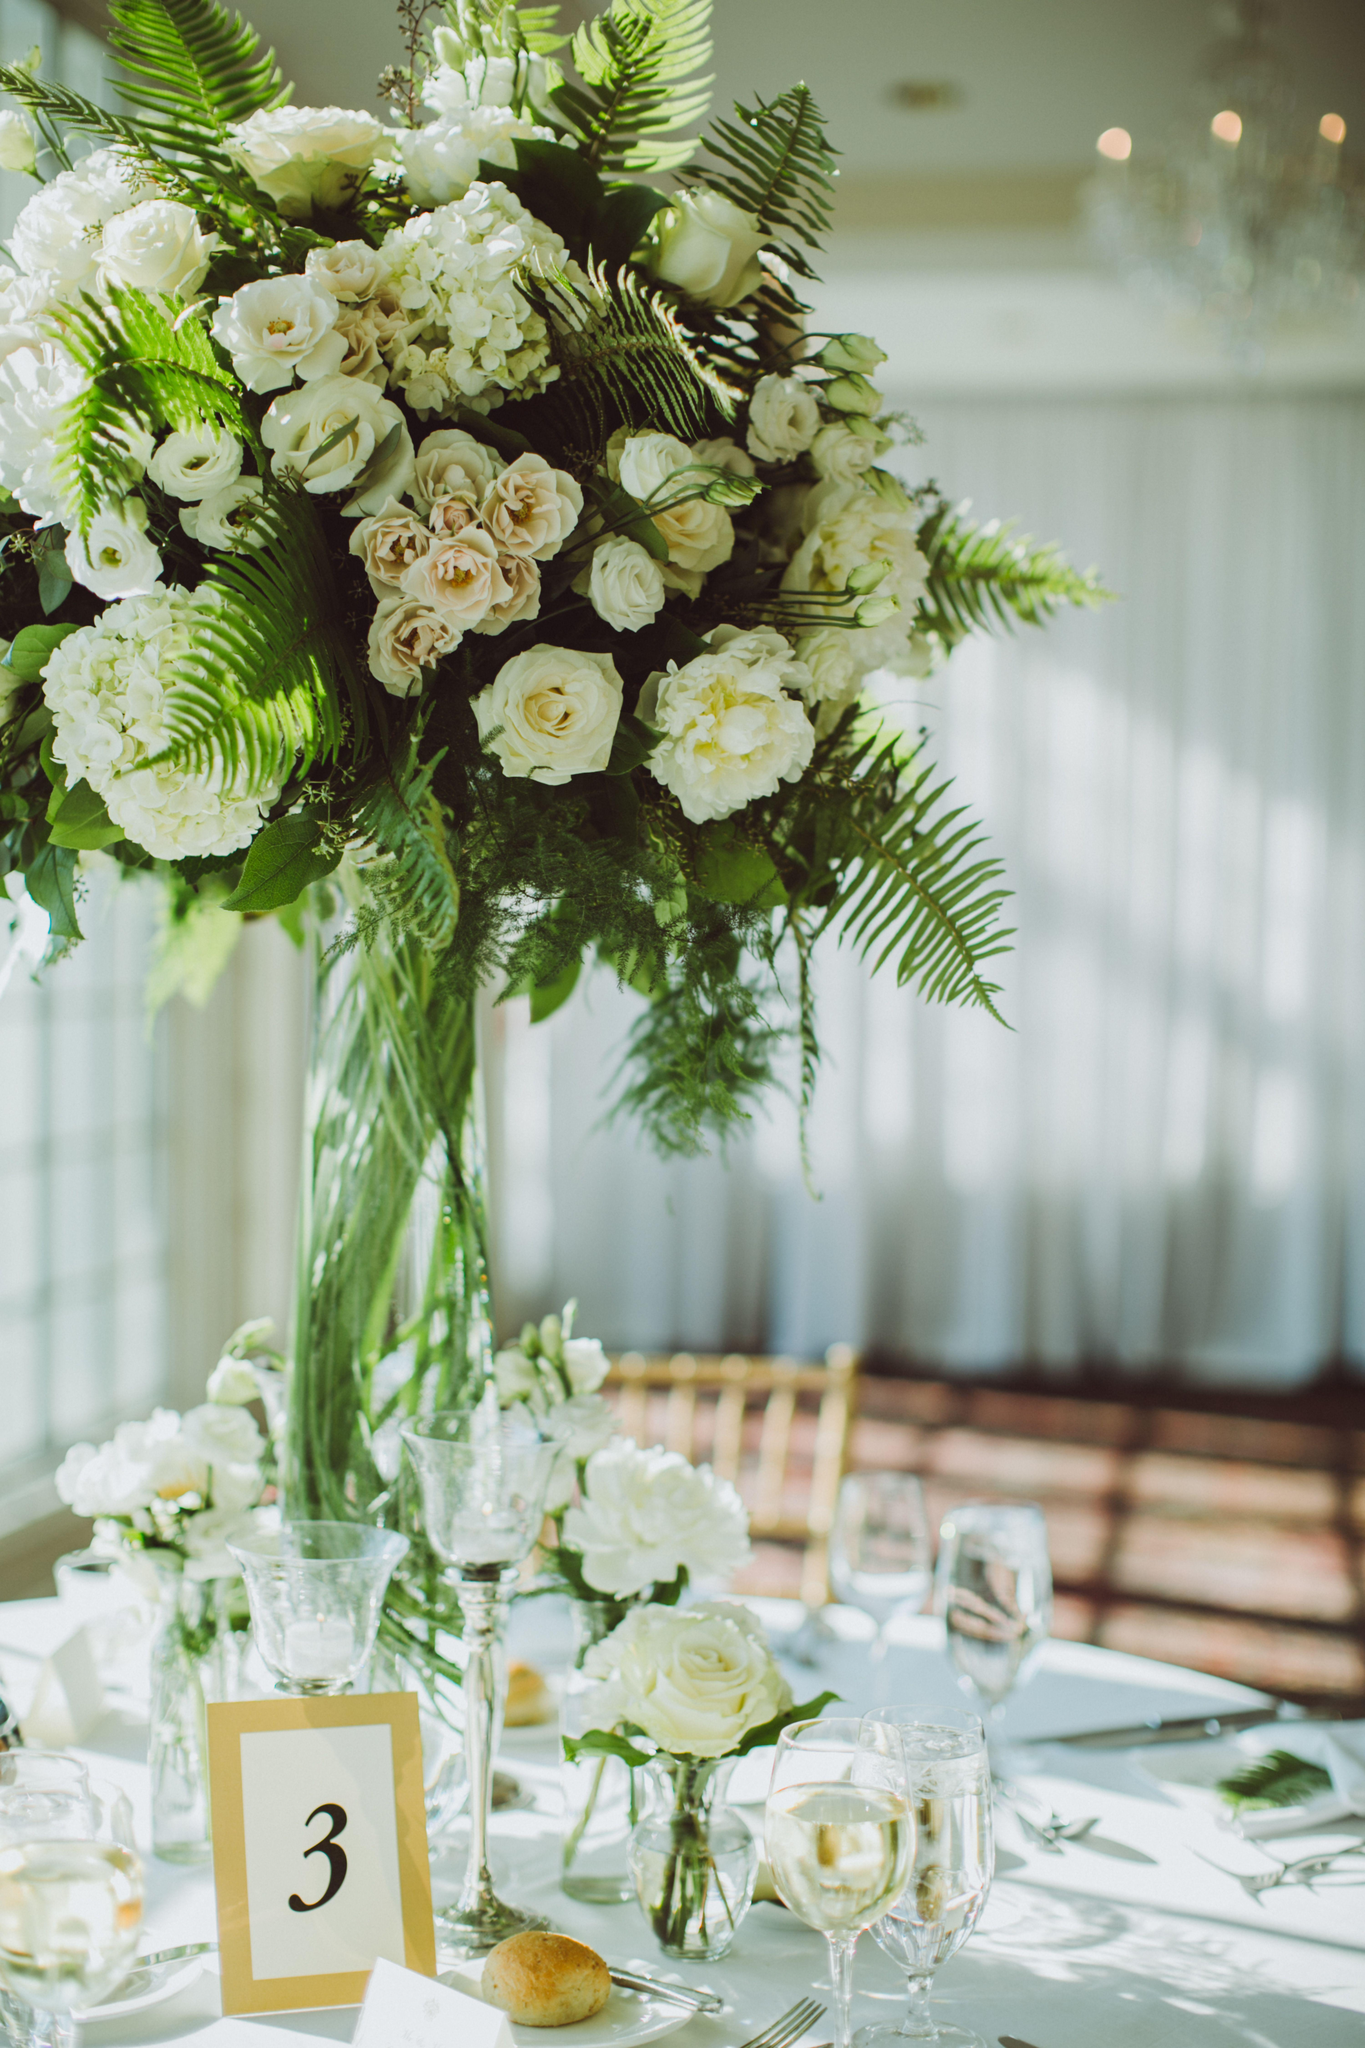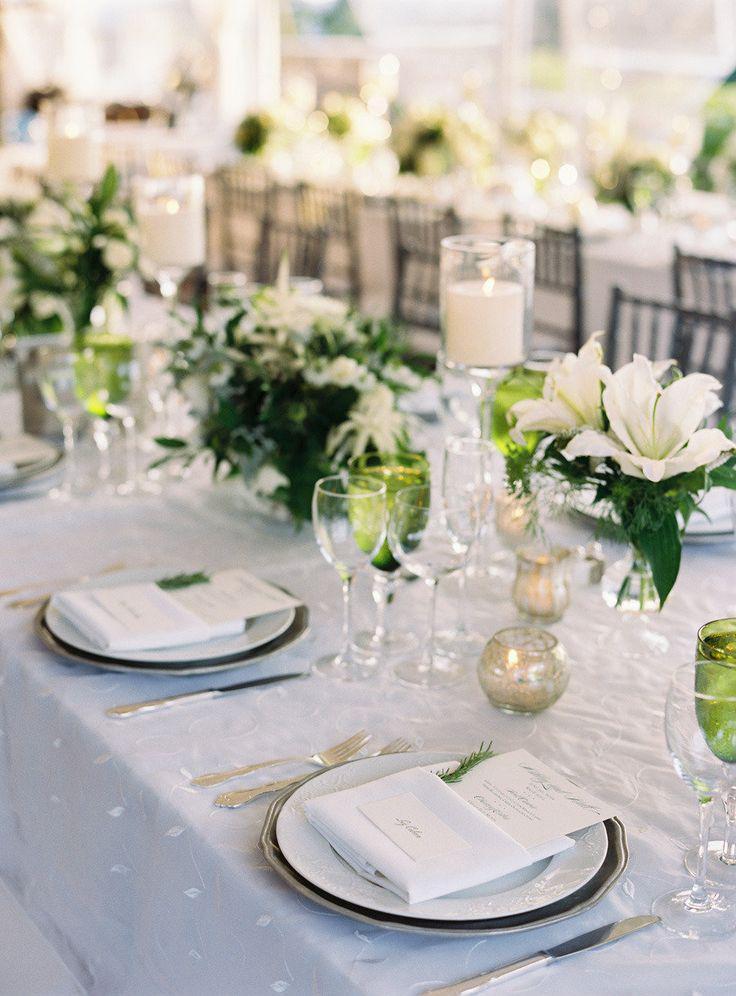The first image is the image on the left, the second image is the image on the right. Evaluate the accuracy of this statement regarding the images: "A single numbered label is on top of a decorated table.". Is it true? Answer yes or no. Yes. The first image is the image on the left, the second image is the image on the right. For the images shown, is this caption "A plant with no flowers in a tall vase is used as a centerpiece on the table." true? Answer yes or no. No. 